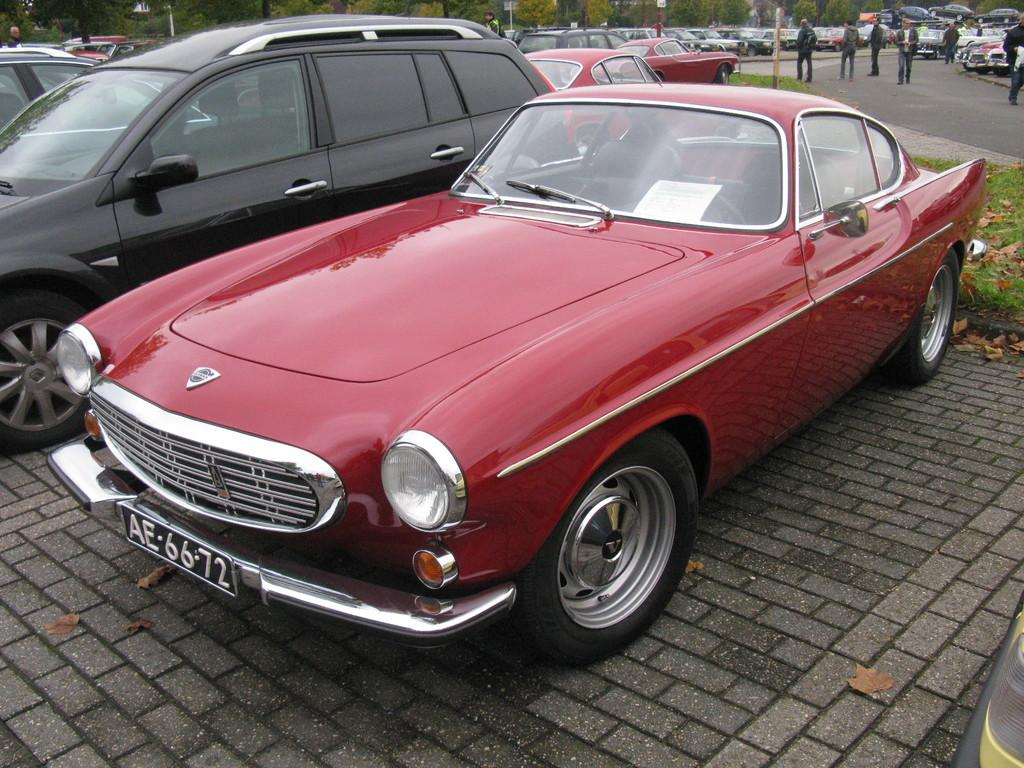What can be seen moving in the image? There are vehicles in the image. What type of natural elements can be seen at the top of the image? Trees are visible at the top of the image. What are the tall, thin structures at the top of the image? Poles are present at the top of the image. Where are the people located in the image? There are people on the road in the top right corner of the image. Can you tell me the relation between the people and the tin in the image? There is no tin present in the image, and therefore no relation can be established between the people and a tin. 